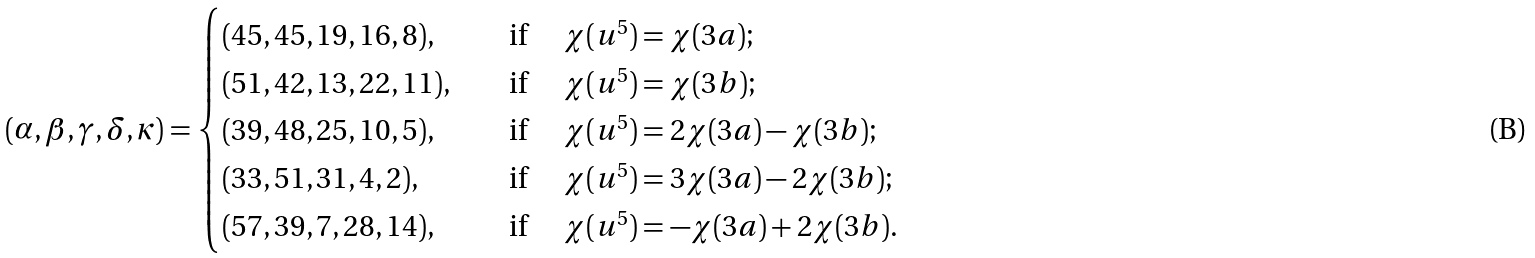Convert formula to latex. <formula><loc_0><loc_0><loc_500><loc_500>( \alpha , \beta , \gamma , \delta , \kappa ) = \begin{cases} ( 4 5 , 4 5 , 1 9 , 1 6 , 8 ) , & \quad \text {if } \quad \chi ( u ^ { 5 } ) = \chi ( 3 a ) ; \\ ( 5 1 , 4 2 , 1 3 , 2 2 , 1 1 ) , & \quad \text {if } \quad \chi ( u ^ { 5 } ) = \chi ( 3 b ) ; \\ ( 3 9 , 4 8 , 2 5 , 1 0 , 5 ) , & \quad \text {if } \quad \chi ( u ^ { 5 } ) = 2 \chi ( 3 a ) - \chi ( 3 b ) ; \\ ( 3 3 , 5 1 , 3 1 , 4 , 2 ) , & \quad \text {if } \quad \chi ( u ^ { 5 } ) = 3 \chi ( 3 a ) - 2 \chi ( 3 b ) ; \\ ( 5 7 , 3 9 , 7 , 2 8 , 1 4 ) , & \quad \text {if } \quad \chi ( u ^ { 5 } ) = - \chi ( 3 a ) + 2 \chi ( 3 b ) . \\ \end{cases}</formula> 